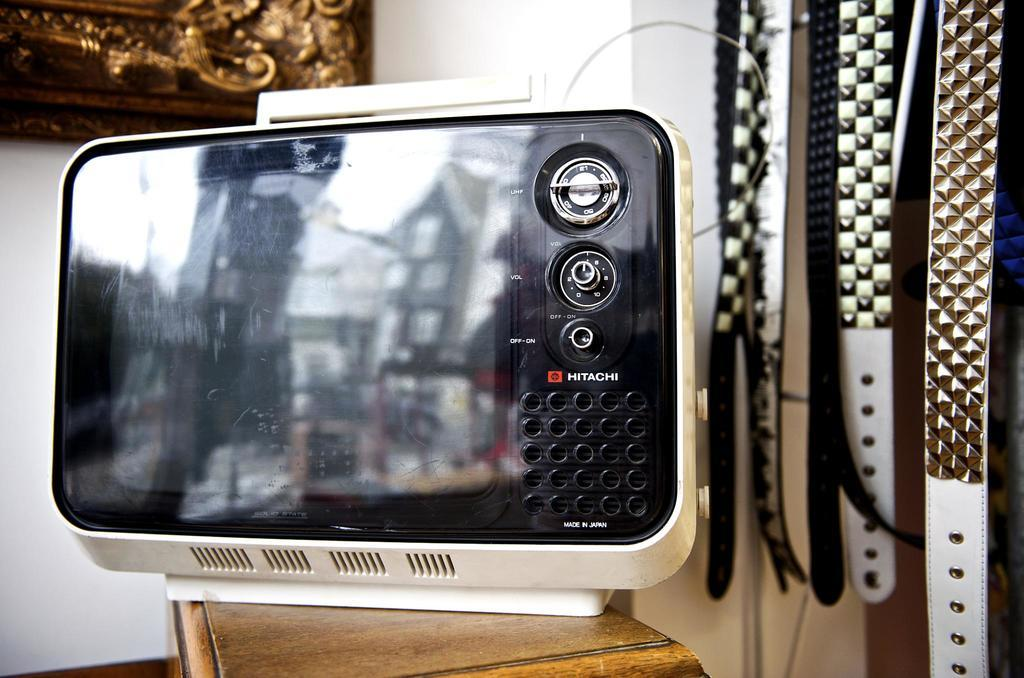<image>
Give a short and clear explanation of the subsequent image. a Hitachi label on the front of an appliance 